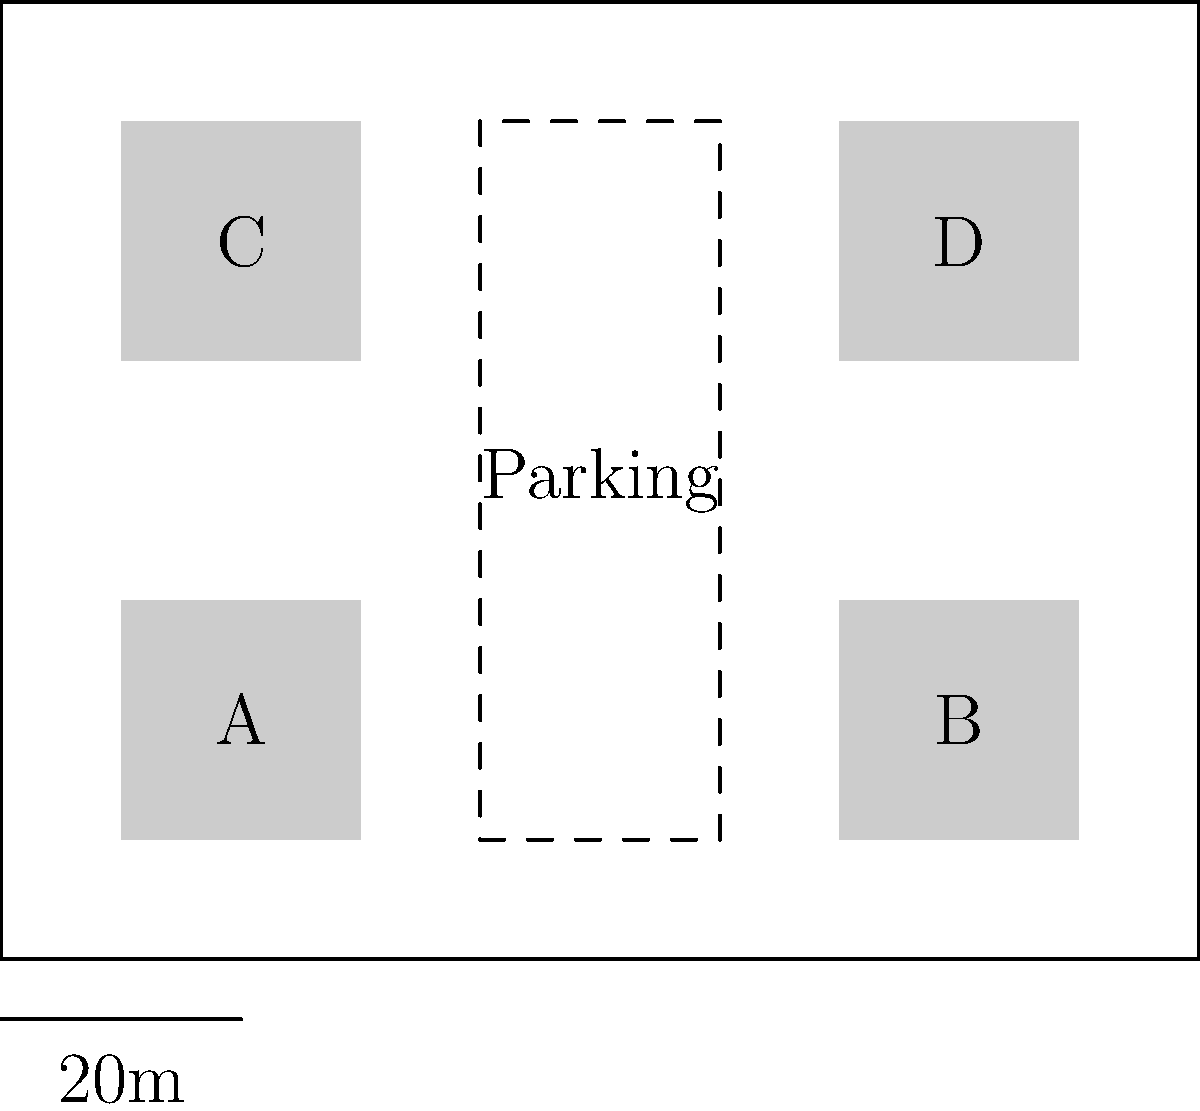Based on the site plan provided, which layout would be most efficient for a shared parking lot serving the four local businesses (A, B, C, and D) while maximizing the number of parking spaces? Consider factors such as accessibility, traffic flow, and space utilization. To determine the optimal layout for a shared parking lot, we need to consider several factors:

1. Central location: The parking area should be easily accessible to all four businesses.

2. Space efficiency: Maximize the number of parking spaces within the available area.

3. Traffic flow: Ensure smooth entry and exit for vehicles.

4. Pedestrian access: Provide safe and convenient paths for customers to reach each business.

5. Future expansion: Allow for potential growth of businesses or parking needs.

Analyzing the site plan:

1. The dashed area between the four buildings is the most suitable location for the shared parking lot.

2. This central location provides equal access to all four businesses (A, B, C, and D).

3. A rectangular layout (40m x 60m) maximizes space utilization for parking spaces.

4. Entrances can be placed on both ends of the parking area to improve traffic flow.

5. Pedestrian walkways can be added along the edges of the parking lot for safe access to each business.

6. The chosen location leaves room for potential expansion of businesses or additional parking if needed.

To optimize the layout:

1. Use angled parking spaces (e.g., 45 or 60 degrees) to maximize the number of spots.

2. Include a central driving lane for easy navigation.

3. Add clearly marked pedestrian crossings connecting the parking area to each business.

4. Implement proper lighting and signage for safety and ease of use.

5. Consider adding green spaces or landscaping elements to improve aesthetics and provide a buffer between the parking area and businesses.

This layout efficiently serves all four businesses while maximizing parking capacity and allowing for future growth.
Answer: Central rectangular lot with angled spaces, central driving lane, and pedestrian walkways. 